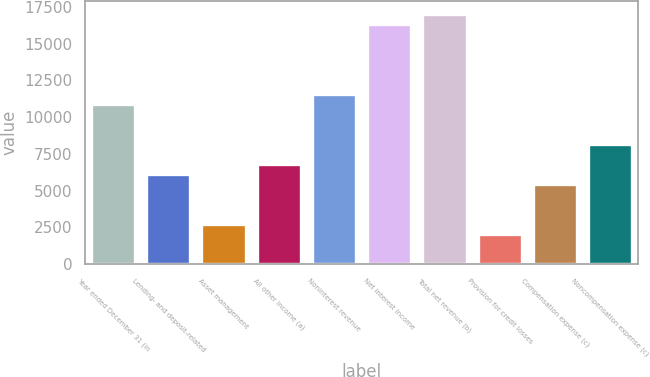<chart> <loc_0><loc_0><loc_500><loc_500><bar_chart><fcel>Year ended December 31 (in<fcel>Lending- and deposit-related<fcel>Asset management<fcel>All other income (a)<fcel>Noninterest revenue<fcel>Net interest income<fcel>Total net revenue (b)<fcel>Provision for credit losses<fcel>Compensation expense (c)<fcel>Noncompensation expense (c)<nl><fcel>10903.8<fcel>6145.2<fcel>2746.2<fcel>6825<fcel>11583.6<fcel>16342.2<fcel>17022<fcel>2066.4<fcel>5465.4<fcel>8184.6<nl></chart> 